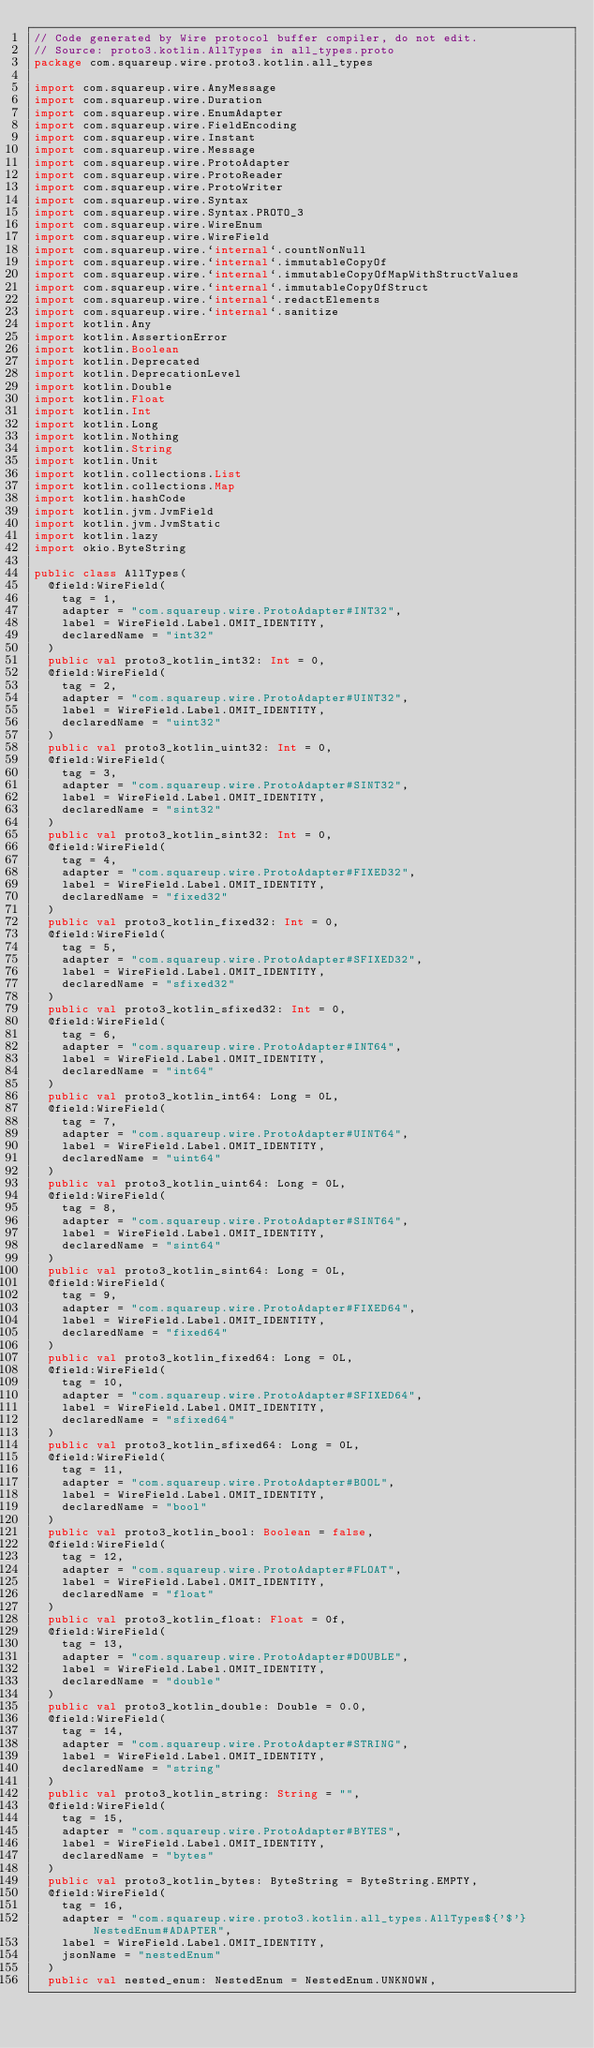Convert code to text. <code><loc_0><loc_0><loc_500><loc_500><_Kotlin_>// Code generated by Wire protocol buffer compiler, do not edit.
// Source: proto3.kotlin.AllTypes in all_types.proto
package com.squareup.wire.proto3.kotlin.all_types

import com.squareup.wire.AnyMessage
import com.squareup.wire.Duration
import com.squareup.wire.EnumAdapter
import com.squareup.wire.FieldEncoding
import com.squareup.wire.Instant
import com.squareup.wire.Message
import com.squareup.wire.ProtoAdapter
import com.squareup.wire.ProtoReader
import com.squareup.wire.ProtoWriter
import com.squareup.wire.Syntax
import com.squareup.wire.Syntax.PROTO_3
import com.squareup.wire.WireEnum
import com.squareup.wire.WireField
import com.squareup.wire.`internal`.countNonNull
import com.squareup.wire.`internal`.immutableCopyOf
import com.squareup.wire.`internal`.immutableCopyOfMapWithStructValues
import com.squareup.wire.`internal`.immutableCopyOfStruct
import com.squareup.wire.`internal`.redactElements
import com.squareup.wire.`internal`.sanitize
import kotlin.Any
import kotlin.AssertionError
import kotlin.Boolean
import kotlin.Deprecated
import kotlin.DeprecationLevel
import kotlin.Double
import kotlin.Float
import kotlin.Int
import kotlin.Long
import kotlin.Nothing
import kotlin.String
import kotlin.Unit
import kotlin.collections.List
import kotlin.collections.Map
import kotlin.hashCode
import kotlin.jvm.JvmField
import kotlin.jvm.JvmStatic
import kotlin.lazy
import okio.ByteString

public class AllTypes(
  @field:WireField(
    tag = 1,
    adapter = "com.squareup.wire.ProtoAdapter#INT32",
    label = WireField.Label.OMIT_IDENTITY,
    declaredName = "int32"
  )
  public val proto3_kotlin_int32: Int = 0,
  @field:WireField(
    tag = 2,
    adapter = "com.squareup.wire.ProtoAdapter#UINT32",
    label = WireField.Label.OMIT_IDENTITY,
    declaredName = "uint32"
  )
  public val proto3_kotlin_uint32: Int = 0,
  @field:WireField(
    tag = 3,
    adapter = "com.squareup.wire.ProtoAdapter#SINT32",
    label = WireField.Label.OMIT_IDENTITY,
    declaredName = "sint32"
  )
  public val proto3_kotlin_sint32: Int = 0,
  @field:WireField(
    tag = 4,
    adapter = "com.squareup.wire.ProtoAdapter#FIXED32",
    label = WireField.Label.OMIT_IDENTITY,
    declaredName = "fixed32"
  )
  public val proto3_kotlin_fixed32: Int = 0,
  @field:WireField(
    tag = 5,
    adapter = "com.squareup.wire.ProtoAdapter#SFIXED32",
    label = WireField.Label.OMIT_IDENTITY,
    declaredName = "sfixed32"
  )
  public val proto3_kotlin_sfixed32: Int = 0,
  @field:WireField(
    tag = 6,
    adapter = "com.squareup.wire.ProtoAdapter#INT64",
    label = WireField.Label.OMIT_IDENTITY,
    declaredName = "int64"
  )
  public val proto3_kotlin_int64: Long = 0L,
  @field:WireField(
    tag = 7,
    adapter = "com.squareup.wire.ProtoAdapter#UINT64",
    label = WireField.Label.OMIT_IDENTITY,
    declaredName = "uint64"
  )
  public val proto3_kotlin_uint64: Long = 0L,
  @field:WireField(
    tag = 8,
    adapter = "com.squareup.wire.ProtoAdapter#SINT64",
    label = WireField.Label.OMIT_IDENTITY,
    declaredName = "sint64"
  )
  public val proto3_kotlin_sint64: Long = 0L,
  @field:WireField(
    tag = 9,
    adapter = "com.squareup.wire.ProtoAdapter#FIXED64",
    label = WireField.Label.OMIT_IDENTITY,
    declaredName = "fixed64"
  )
  public val proto3_kotlin_fixed64: Long = 0L,
  @field:WireField(
    tag = 10,
    adapter = "com.squareup.wire.ProtoAdapter#SFIXED64",
    label = WireField.Label.OMIT_IDENTITY,
    declaredName = "sfixed64"
  )
  public val proto3_kotlin_sfixed64: Long = 0L,
  @field:WireField(
    tag = 11,
    adapter = "com.squareup.wire.ProtoAdapter#BOOL",
    label = WireField.Label.OMIT_IDENTITY,
    declaredName = "bool"
  )
  public val proto3_kotlin_bool: Boolean = false,
  @field:WireField(
    tag = 12,
    adapter = "com.squareup.wire.ProtoAdapter#FLOAT",
    label = WireField.Label.OMIT_IDENTITY,
    declaredName = "float"
  )
  public val proto3_kotlin_float: Float = 0f,
  @field:WireField(
    tag = 13,
    adapter = "com.squareup.wire.ProtoAdapter#DOUBLE",
    label = WireField.Label.OMIT_IDENTITY,
    declaredName = "double"
  )
  public val proto3_kotlin_double: Double = 0.0,
  @field:WireField(
    tag = 14,
    adapter = "com.squareup.wire.ProtoAdapter#STRING",
    label = WireField.Label.OMIT_IDENTITY,
    declaredName = "string"
  )
  public val proto3_kotlin_string: String = "",
  @field:WireField(
    tag = 15,
    adapter = "com.squareup.wire.ProtoAdapter#BYTES",
    label = WireField.Label.OMIT_IDENTITY,
    declaredName = "bytes"
  )
  public val proto3_kotlin_bytes: ByteString = ByteString.EMPTY,
  @field:WireField(
    tag = 16,
    adapter = "com.squareup.wire.proto3.kotlin.all_types.AllTypes${'$'}NestedEnum#ADAPTER",
    label = WireField.Label.OMIT_IDENTITY,
    jsonName = "nestedEnum"
  )
  public val nested_enum: NestedEnum = NestedEnum.UNKNOWN,</code> 